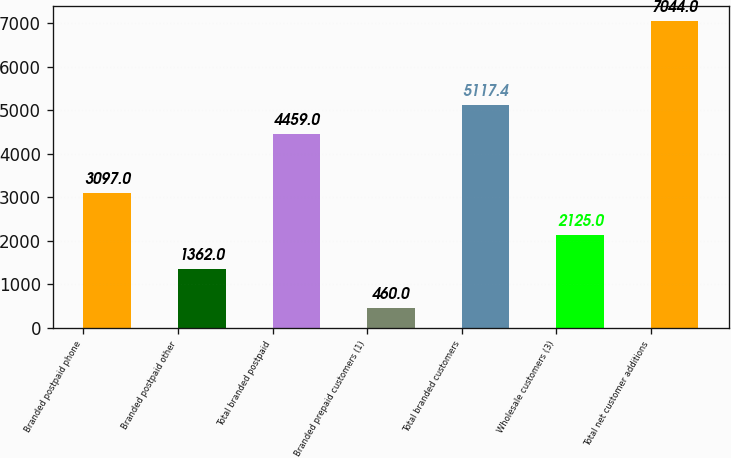Convert chart. <chart><loc_0><loc_0><loc_500><loc_500><bar_chart><fcel>Branded postpaid phone<fcel>Branded postpaid other<fcel>Total branded postpaid<fcel>Branded prepaid customers (1)<fcel>Total branded customers<fcel>Wholesale customers (3)<fcel>Total net customer additions<nl><fcel>3097<fcel>1362<fcel>4459<fcel>460<fcel>5117.4<fcel>2125<fcel>7044<nl></chart> 